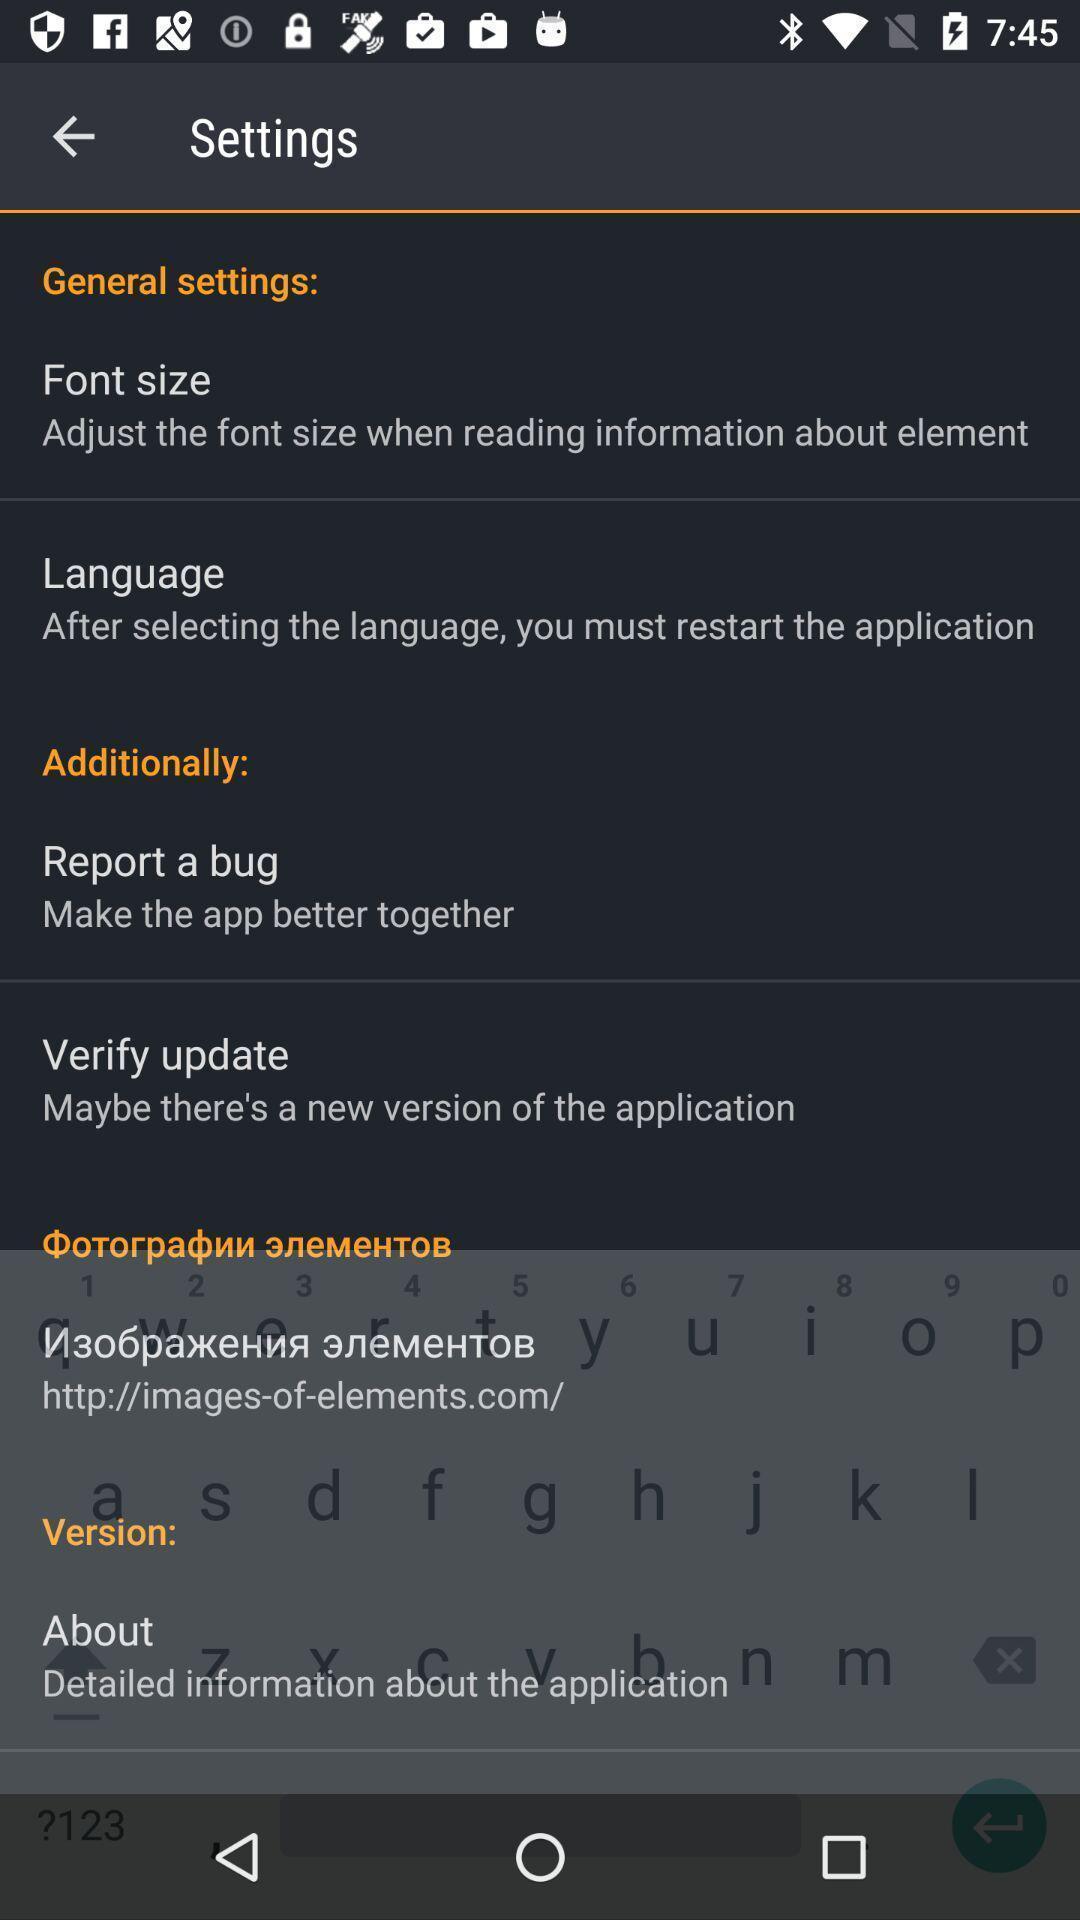Provide a detailed account of this screenshot. Screen showing settings page. 